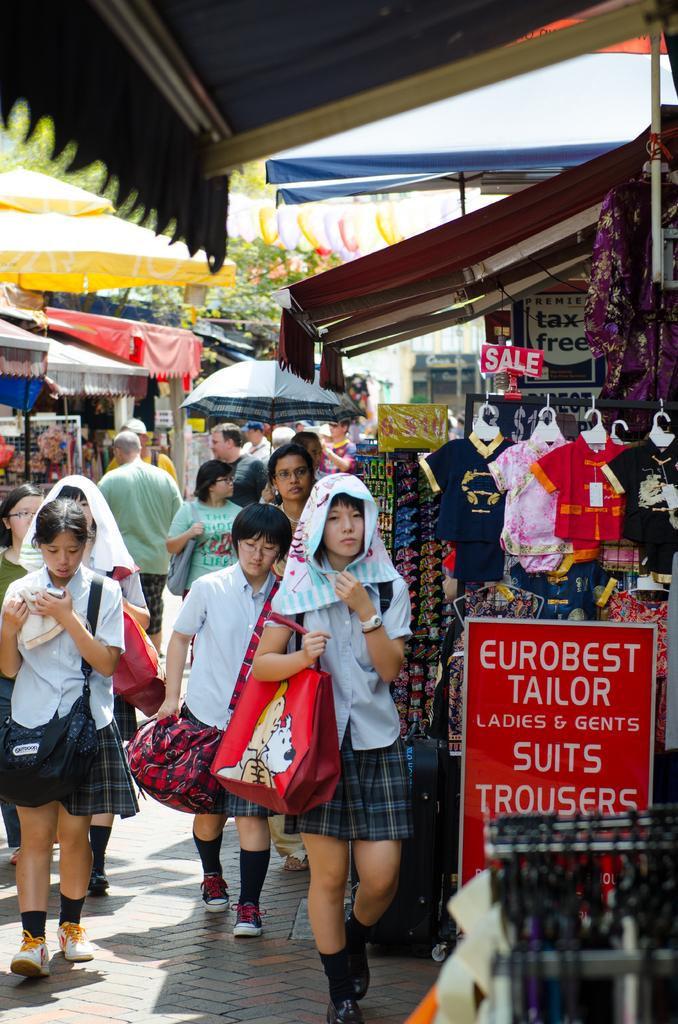How many people can be seen in the image? There are people in the image, but the exact number is not specified. What type of temporary shelter is present in the image? There are tents in the image. What natural element is visible in the image? There is a tree in the image. What type of clothing can be seen in the image? Clothes are visible in the image. What kind of signage is present in the image? There is an information board in the image. What object is used for protection against rain or sun in the image? An umbrella is visible far in the image. What type of flat, rigid material is present in the image? There are boards in the image. What accessory are some people wearing in the image? Some people are wearing bags. How many horses are tied to the tree in the image? There are no horses present in the image. What type of cushion is placed on the ground near the tents? There is no cushion present in the image. 